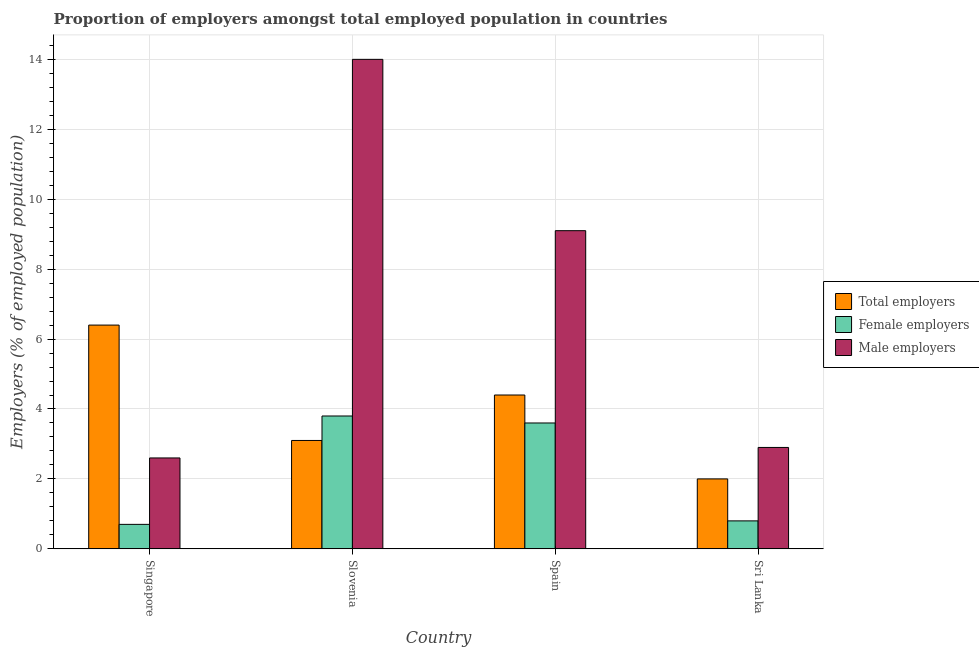How many different coloured bars are there?
Offer a very short reply. 3. How many groups of bars are there?
Your answer should be compact. 4. Are the number of bars per tick equal to the number of legend labels?
Your answer should be very brief. Yes. How many bars are there on the 1st tick from the left?
Your answer should be compact. 3. How many bars are there on the 1st tick from the right?
Offer a very short reply. 3. What is the label of the 4th group of bars from the left?
Make the answer very short. Sri Lanka. In how many cases, is the number of bars for a given country not equal to the number of legend labels?
Make the answer very short. 0. What is the percentage of female employers in Slovenia?
Provide a short and direct response. 3.8. In which country was the percentage of total employers maximum?
Offer a very short reply. Singapore. In which country was the percentage of male employers minimum?
Offer a terse response. Singapore. What is the total percentage of male employers in the graph?
Provide a succinct answer. 28.6. What is the difference between the percentage of total employers in Spain and that in Sri Lanka?
Offer a terse response. 2.4. What is the difference between the percentage of total employers in Sri Lanka and the percentage of female employers in Singapore?
Your answer should be compact. 1.3. What is the average percentage of total employers per country?
Make the answer very short. 3.98. What is the difference between the percentage of female employers and percentage of male employers in Singapore?
Provide a short and direct response. -1.9. In how many countries, is the percentage of male employers greater than 14 %?
Make the answer very short. 0. What is the ratio of the percentage of total employers in Spain to that in Sri Lanka?
Your response must be concise. 2.2. Is the percentage of total employers in Singapore less than that in Slovenia?
Offer a terse response. No. Is the difference between the percentage of total employers in Slovenia and Sri Lanka greater than the difference between the percentage of female employers in Slovenia and Sri Lanka?
Your answer should be compact. No. What is the difference between the highest and the second highest percentage of total employers?
Offer a terse response. 2. What is the difference between the highest and the lowest percentage of female employers?
Offer a terse response. 3.1. In how many countries, is the percentage of male employers greater than the average percentage of male employers taken over all countries?
Your response must be concise. 2. Is the sum of the percentage of male employers in Singapore and Sri Lanka greater than the maximum percentage of total employers across all countries?
Give a very brief answer. No. What does the 3rd bar from the left in Slovenia represents?
Ensure brevity in your answer.  Male employers. What does the 1st bar from the right in Sri Lanka represents?
Give a very brief answer. Male employers. How many bars are there?
Your answer should be very brief. 12. Are all the bars in the graph horizontal?
Your response must be concise. No. Does the graph contain any zero values?
Provide a succinct answer. No. Does the graph contain grids?
Provide a short and direct response. Yes. How are the legend labels stacked?
Offer a very short reply. Vertical. What is the title of the graph?
Give a very brief answer. Proportion of employers amongst total employed population in countries. Does "Profit Tax" appear as one of the legend labels in the graph?
Make the answer very short. No. What is the label or title of the X-axis?
Make the answer very short. Country. What is the label or title of the Y-axis?
Your answer should be compact. Employers (% of employed population). What is the Employers (% of employed population) in Total employers in Singapore?
Your answer should be compact. 6.4. What is the Employers (% of employed population) of Female employers in Singapore?
Your answer should be very brief. 0.7. What is the Employers (% of employed population) in Male employers in Singapore?
Provide a succinct answer. 2.6. What is the Employers (% of employed population) in Total employers in Slovenia?
Give a very brief answer. 3.1. What is the Employers (% of employed population) of Female employers in Slovenia?
Your answer should be very brief. 3.8. What is the Employers (% of employed population) in Male employers in Slovenia?
Provide a short and direct response. 14. What is the Employers (% of employed population) in Total employers in Spain?
Your answer should be compact. 4.4. What is the Employers (% of employed population) of Female employers in Spain?
Offer a terse response. 3.6. What is the Employers (% of employed population) of Male employers in Spain?
Your response must be concise. 9.1. What is the Employers (% of employed population) of Total employers in Sri Lanka?
Ensure brevity in your answer.  2. What is the Employers (% of employed population) of Female employers in Sri Lanka?
Offer a terse response. 0.8. What is the Employers (% of employed population) of Male employers in Sri Lanka?
Give a very brief answer. 2.9. Across all countries, what is the maximum Employers (% of employed population) in Total employers?
Your answer should be very brief. 6.4. Across all countries, what is the maximum Employers (% of employed population) of Female employers?
Make the answer very short. 3.8. Across all countries, what is the minimum Employers (% of employed population) of Total employers?
Provide a succinct answer. 2. Across all countries, what is the minimum Employers (% of employed population) in Female employers?
Offer a terse response. 0.7. Across all countries, what is the minimum Employers (% of employed population) in Male employers?
Give a very brief answer. 2.6. What is the total Employers (% of employed population) in Total employers in the graph?
Provide a succinct answer. 15.9. What is the total Employers (% of employed population) of Female employers in the graph?
Make the answer very short. 8.9. What is the total Employers (% of employed population) of Male employers in the graph?
Provide a short and direct response. 28.6. What is the difference between the Employers (% of employed population) of Female employers in Singapore and that in Slovenia?
Your answer should be compact. -3.1. What is the difference between the Employers (% of employed population) in Total employers in Singapore and that in Spain?
Provide a succinct answer. 2. What is the difference between the Employers (% of employed population) in Male employers in Singapore and that in Sri Lanka?
Provide a succinct answer. -0.3. What is the difference between the Employers (% of employed population) in Female employers in Slovenia and that in Spain?
Ensure brevity in your answer.  0.2. What is the difference between the Employers (% of employed population) in Female employers in Slovenia and that in Sri Lanka?
Offer a terse response. 3. What is the difference between the Employers (% of employed population) of Male employers in Slovenia and that in Sri Lanka?
Offer a very short reply. 11.1. What is the difference between the Employers (% of employed population) in Female employers in Spain and that in Sri Lanka?
Ensure brevity in your answer.  2.8. What is the difference between the Employers (% of employed population) of Total employers in Singapore and the Employers (% of employed population) of Male employers in Slovenia?
Offer a very short reply. -7.6. What is the difference between the Employers (% of employed population) of Female employers in Singapore and the Employers (% of employed population) of Male employers in Slovenia?
Keep it short and to the point. -13.3. What is the difference between the Employers (% of employed population) of Total employers in Singapore and the Employers (% of employed population) of Male employers in Spain?
Your answer should be very brief. -2.7. What is the difference between the Employers (% of employed population) in Female employers in Singapore and the Employers (% of employed population) in Male employers in Sri Lanka?
Your answer should be very brief. -2.2. What is the difference between the Employers (% of employed population) in Total employers in Slovenia and the Employers (% of employed population) in Male employers in Spain?
Your answer should be compact. -6. What is the difference between the Employers (% of employed population) of Female employers in Slovenia and the Employers (% of employed population) of Male employers in Spain?
Offer a terse response. -5.3. What is the difference between the Employers (% of employed population) in Total employers in Spain and the Employers (% of employed population) in Male employers in Sri Lanka?
Keep it short and to the point. 1.5. What is the average Employers (% of employed population) in Total employers per country?
Keep it short and to the point. 3.98. What is the average Employers (% of employed population) in Female employers per country?
Offer a very short reply. 2.23. What is the average Employers (% of employed population) of Male employers per country?
Make the answer very short. 7.15. What is the difference between the Employers (% of employed population) of Female employers and Employers (% of employed population) of Male employers in Singapore?
Your answer should be very brief. -1.9. What is the difference between the Employers (% of employed population) in Total employers and Employers (% of employed population) in Female employers in Slovenia?
Offer a terse response. -0.7. What is the difference between the Employers (% of employed population) of Female employers and Employers (% of employed population) of Male employers in Spain?
Make the answer very short. -5.5. What is the difference between the Employers (% of employed population) of Female employers and Employers (% of employed population) of Male employers in Sri Lanka?
Offer a very short reply. -2.1. What is the ratio of the Employers (% of employed population) of Total employers in Singapore to that in Slovenia?
Provide a short and direct response. 2.06. What is the ratio of the Employers (% of employed population) in Female employers in Singapore to that in Slovenia?
Your answer should be very brief. 0.18. What is the ratio of the Employers (% of employed population) in Male employers in Singapore to that in Slovenia?
Make the answer very short. 0.19. What is the ratio of the Employers (% of employed population) in Total employers in Singapore to that in Spain?
Ensure brevity in your answer.  1.45. What is the ratio of the Employers (% of employed population) in Female employers in Singapore to that in Spain?
Keep it short and to the point. 0.19. What is the ratio of the Employers (% of employed population) of Male employers in Singapore to that in Spain?
Offer a very short reply. 0.29. What is the ratio of the Employers (% of employed population) in Total employers in Singapore to that in Sri Lanka?
Give a very brief answer. 3.2. What is the ratio of the Employers (% of employed population) of Male employers in Singapore to that in Sri Lanka?
Provide a short and direct response. 0.9. What is the ratio of the Employers (% of employed population) of Total employers in Slovenia to that in Spain?
Offer a very short reply. 0.7. What is the ratio of the Employers (% of employed population) in Female employers in Slovenia to that in Spain?
Your response must be concise. 1.06. What is the ratio of the Employers (% of employed population) of Male employers in Slovenia to that in Spain?
Your answer should be compact. 1.54. What is the ratio of the Employers (% of employed population) of Total employers in Slovenia to that in Sri Lanka?
Ensure brevity in your answer.  1.55. What is the ratio of the Employers (% of employed population) in Female employers in Slovenia to that in Sri Lanka?
Provide a short and direct response. 4.75. What is the ratio of the Employers (% of employed population) in Male employers in Slovenia to that in Sri Lanka?
Your answer should be compact. 4.83. What is the ratio of the Employers (% of employed population) in Female employers in Spain to that in Sri Lanka?
Provide a succinct answer. 4.5. What is the ratio of the Employers (% of employed population) of Male employers in Spain to that in Sri Lanka?
Provide a short and direct response. 3.14. What is the difference between the highest and the second highest Employers (% of employed population) in Male employers?
Offer a very short reply. 4.9. What is the difference between the highest and the lowest Employers (% of employed population) in Male employers?
Make the answer very short. 11.4. 